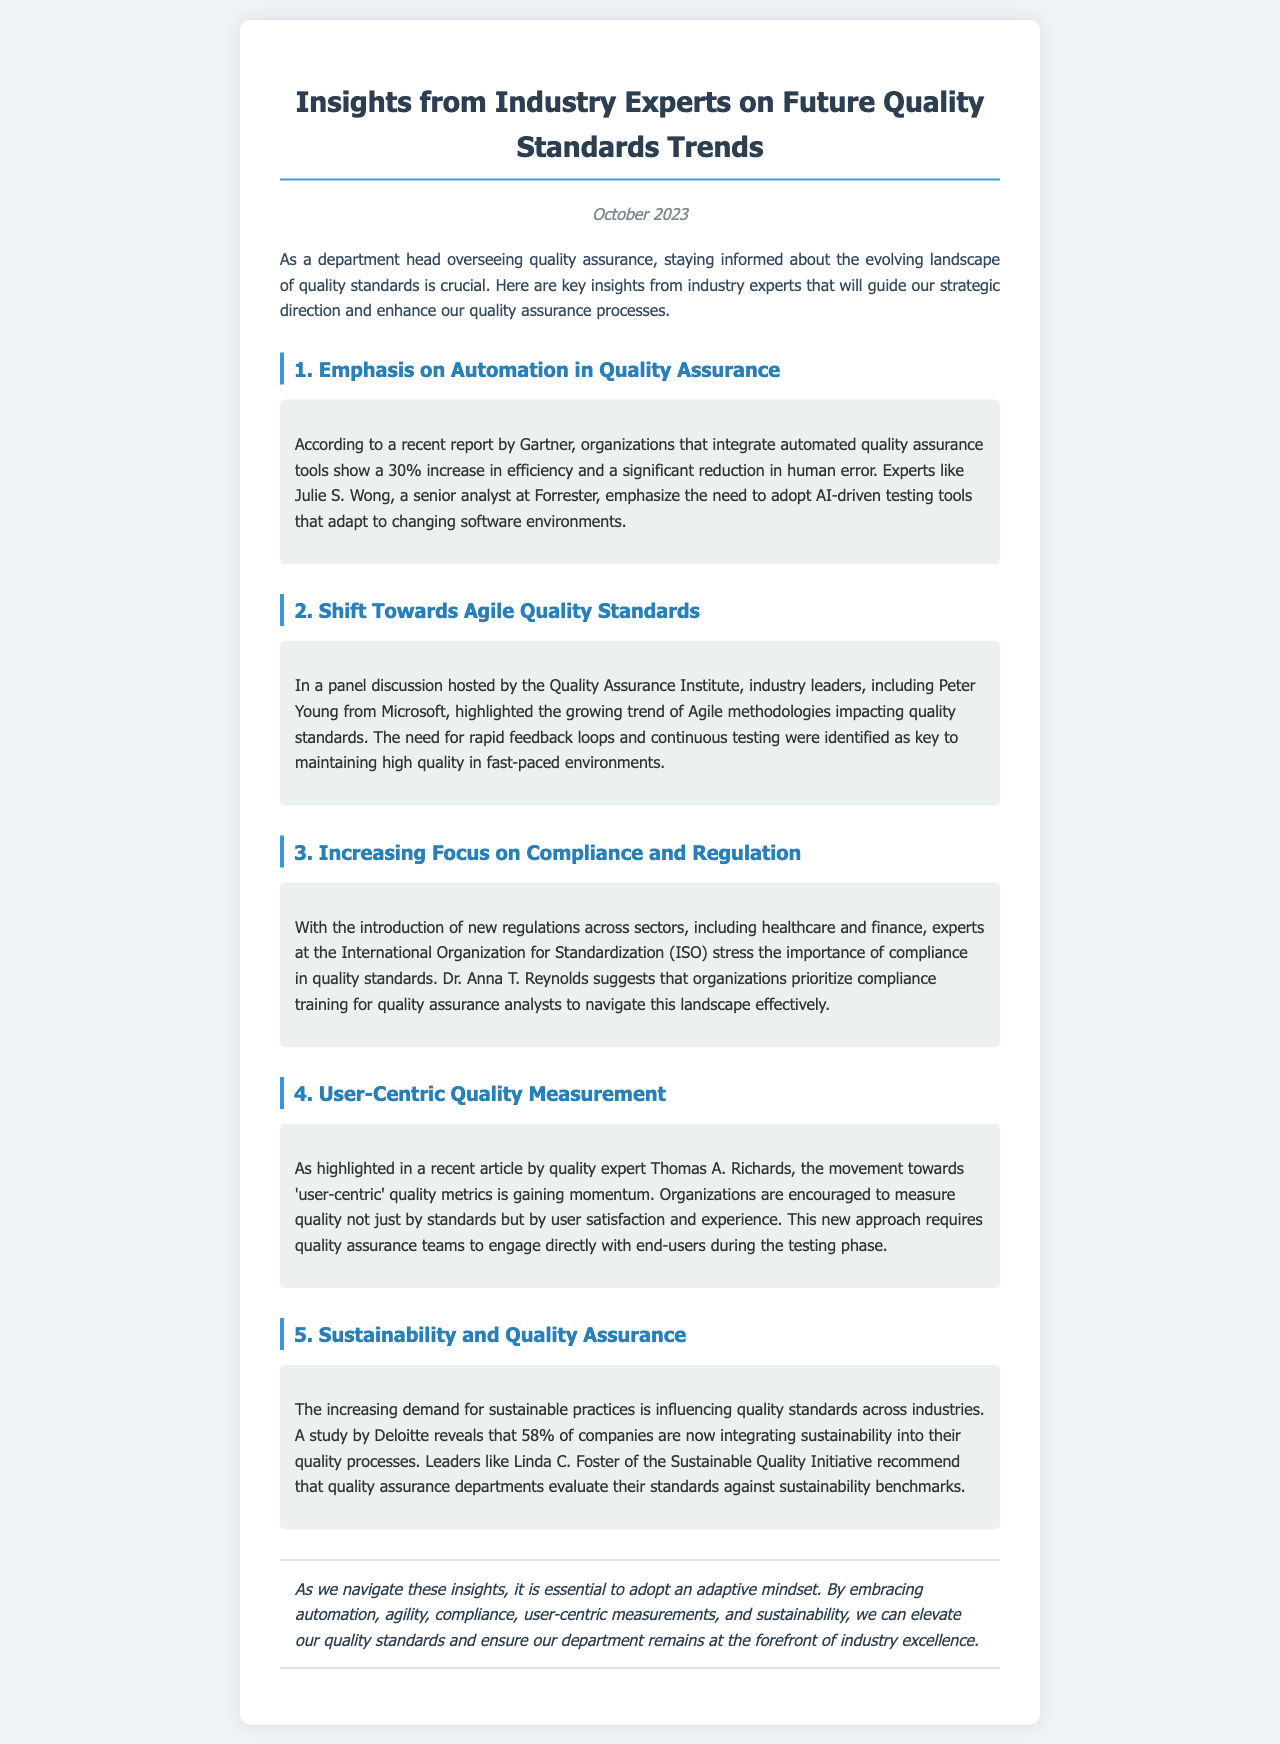What is the title of the newsletter? The title of the newsletter is prominently displayed at the top of the document.
Answer: Insights from Industry Experts on Future Quality Standards Trends What is the publication date of this newsletter? The publication date is mentioned in the header section of the document.
Answer: October 2023 Who conducted the panel discussion on Agile methodologies? The source of the panel discussion is specified in the second section of the newsletter.
Answer: Quality Assurance Institute What percentage increase in efficiency is reported for organizations using automated quality assurance tools? This statistic is provided in the first section regarding automation tools.
Answer: 30% Which expert suggests compliance training for quality assurance analysts? This information is found in the section discussing compliance and regulation.
Answer: Dr. Anna T. Reynolds What is a key aspect of user-centric quality measurement according to Thomas A. Richards? The focus of user-centric quality metrics is highlighted in the fourth section.
Answer: User satisfaction and experience What do 58% of companies integrate into their quality processes according to Deloitte? This statistic appears in the section discussing sustainability.
Answer: Sustainability What mindset is essential for navigating the insights mentioned in the newsletter? The conclusion emphasizes the importance of a particular mindset.
Answer: Adaptive mindset 